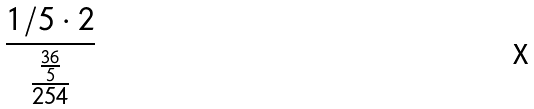Convert formula to latex. <formula><loc_0><loc_0><loc_500><loc_500>\frac { 1 / 5 \cdot 2 } { \frac { \frac { 3 6 } { 5 } } { 2 5 4 } }</formula> 